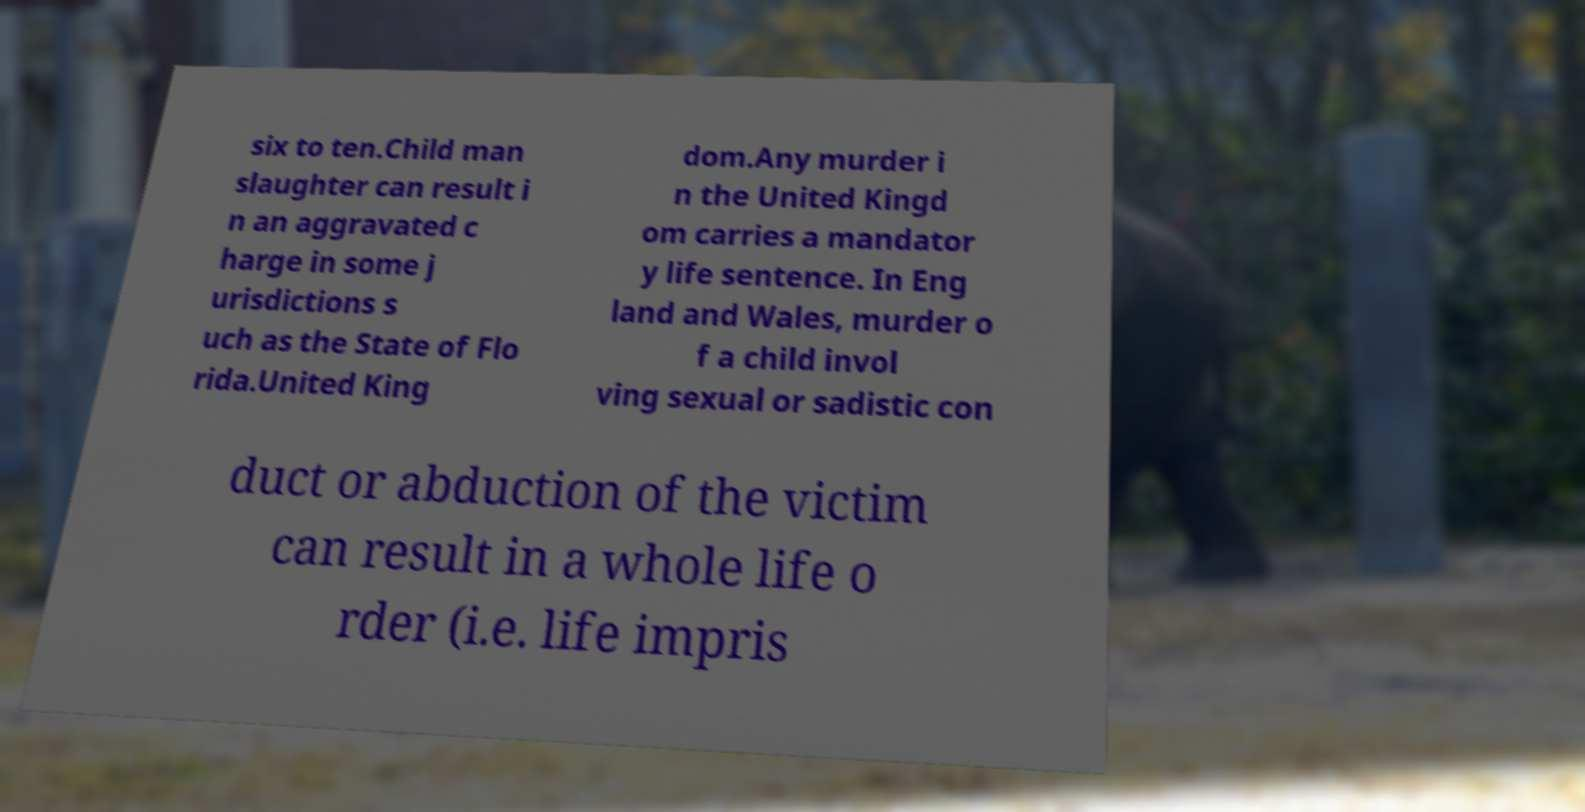Please identify and transcribe the text found in this image. six to ten.Child man slaughter can result i n an aggravated c harge in some j urisdictions s uch as the State of Flo rida.United King dom.Any murder i n the United Kingd om carries a mandator y life sentence. In Eng land and Wales, murder o f a child invol ving sexual or sadistic con duct or abduction of the victim can result in a whole life o rder (i.e. life impris 